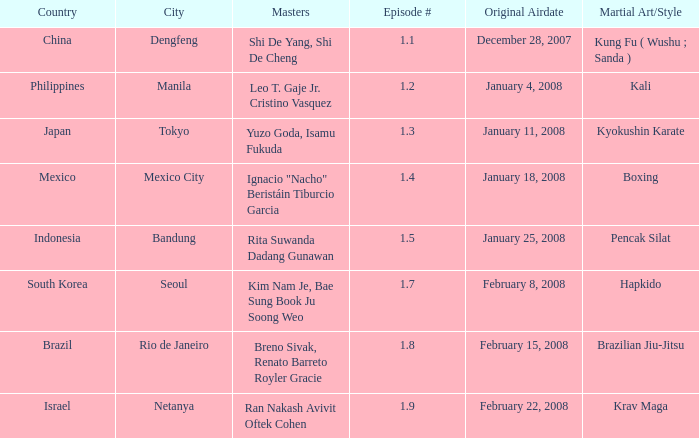Which masters fought in hapkido style? Kim Nam Je, Bae Sung Book Ju Soong Weo. 